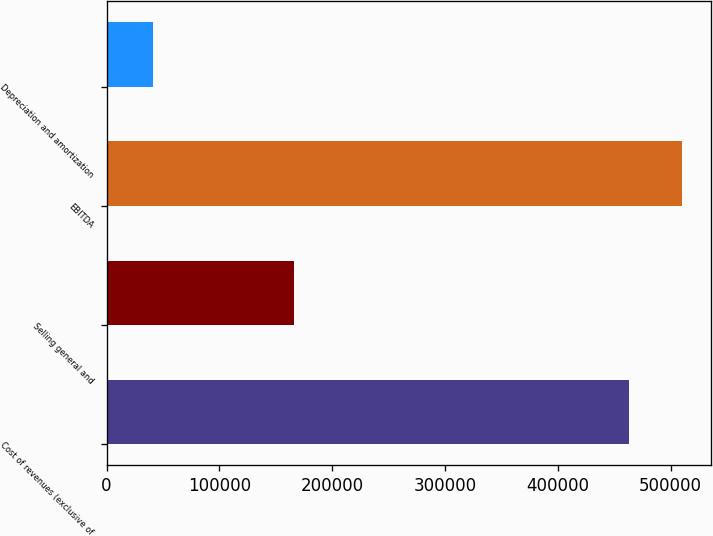Convert chart. <chart><loc_0><loc_0><loc_500><loc_500><bar_chart><fcel>Cost of revenues (exclusive of<fcel>Selling general and<fcel>EBITDA<fcel>Depreciation and amortization<nl><fcel>463473<fcel>166374<fcel>510344<fcel>40728<nl></chart> 